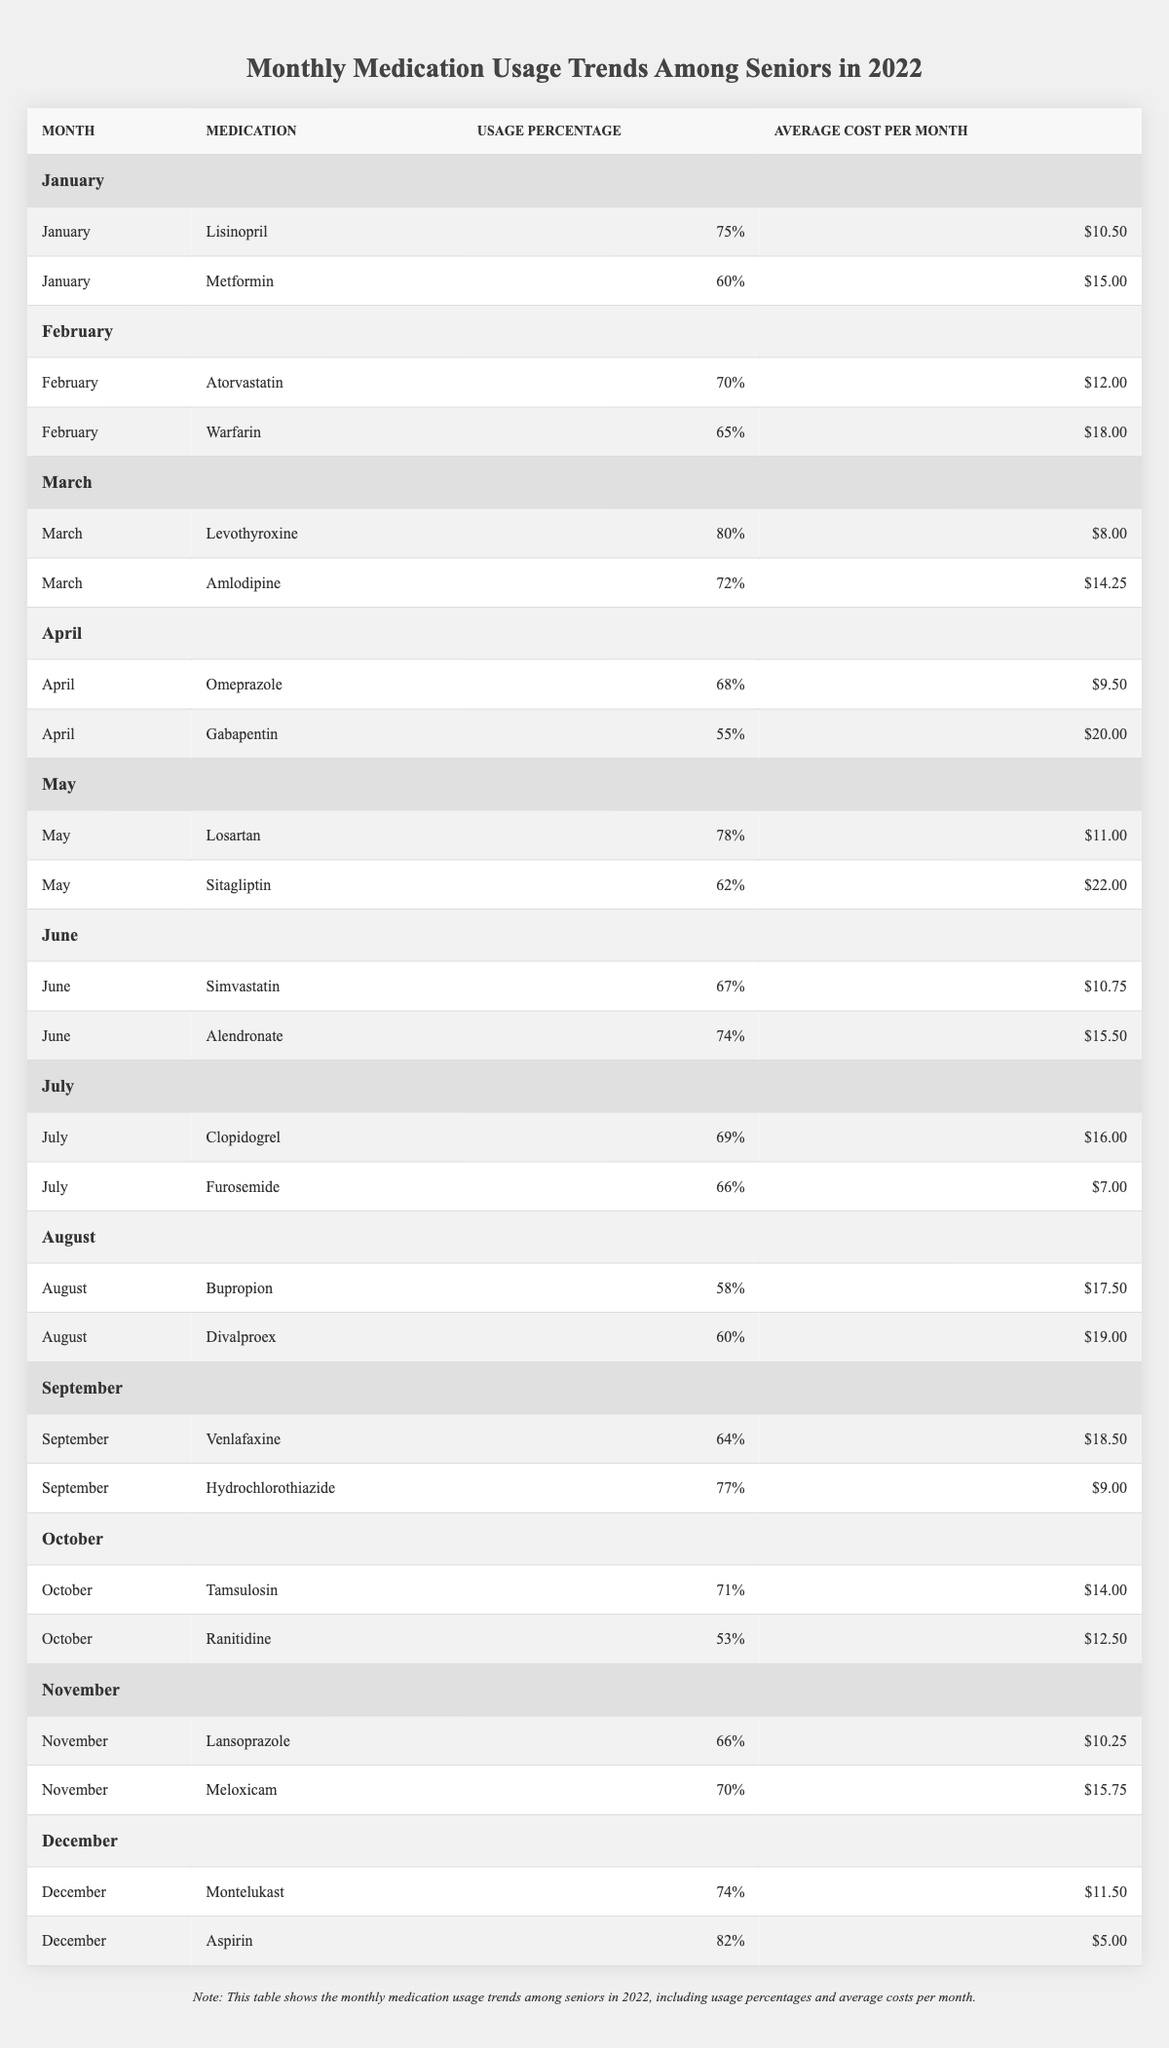What medication had the highest usage percentage in December? In December, the medications listed are Montelukast with a usage percentage of 74% and Aspirin with a usage percentage of 82%. Comparing these, Aspirin has the highest usage percentage at 82%.
Answer: Aspirin What was the average cost of medications used in March? In March, the medications listed are Levothyroxine at $8.00 and Amlodipine at $14.25. To find the average, add the costs: $8.00 + $14.25 = $22.25, then divide by 2, which equals $11.125.
Answer: $11.13 Did any medications report a higher usage percentage than 75% in June? In June, the medications Simvastatin has a usage percentage of 67% and Alendronate has a usage percentage of 74%. Both percentages are less than 75%, so no medications reported a higher percentage in June.
Answer: No Which medication had the lowest average monthly cost in the year? Scanning through each medication's average monthly cost, Aspirin at $5.00 is the lowest among all medications listed in the table.
Answer: Aspirin What medications had a usage percentage above 70% and cost more than $15.00? Checking through the data, Losartan (78%, $11.00), Alendronate (74%, $15.50), and Meloxicam (70%, $15.75) do not meet the cost criterion. The only medication that fits is Warfarin with a usage percentage of 65% and an average cost of $18.00; however, it doesn't meet the percentage criterion either. Thus, there are none.
Answer: None What percentage difference in usage was there between the highest usage medication in January and the highest in February? Lisinopril had the highest usage percentage in January at 75%, and Atorvastatin had the highest in February at 70%. The difference is calculated as 75% - 70% = 5%.
Answer: 5% Which month had an average medication usage percentage above 70%? By examining each month, January (67.5%), March (76%), May (70%), September (70.5%), and December (78%) had an average medication usage percentage above 70%. The months with a percentage greater than 70% are March, May, September, and December.
Answer: March, September, December What is the total average cost of medications in September? In September, Venlafaxine costs $18.50 and Hydrochlorothiazide costs $9.00. Adding these gives $27.50. Therefore, the average cost is $27.50 / 2 = $13.75.
Answer: $13.75 Which medication was used the least often in July? In July, the medications recorded are Clopidogrel with a usage of 69% and Furosemide with a usage of 66%. Furosemide is used less often.
Answer: Furosemide Was the usage of Gabapentin above 60% in April? Gabapentin had a reported usage percentage of 55% in April, which is below 60%. Therefore, the statement is false.
Answer: No 